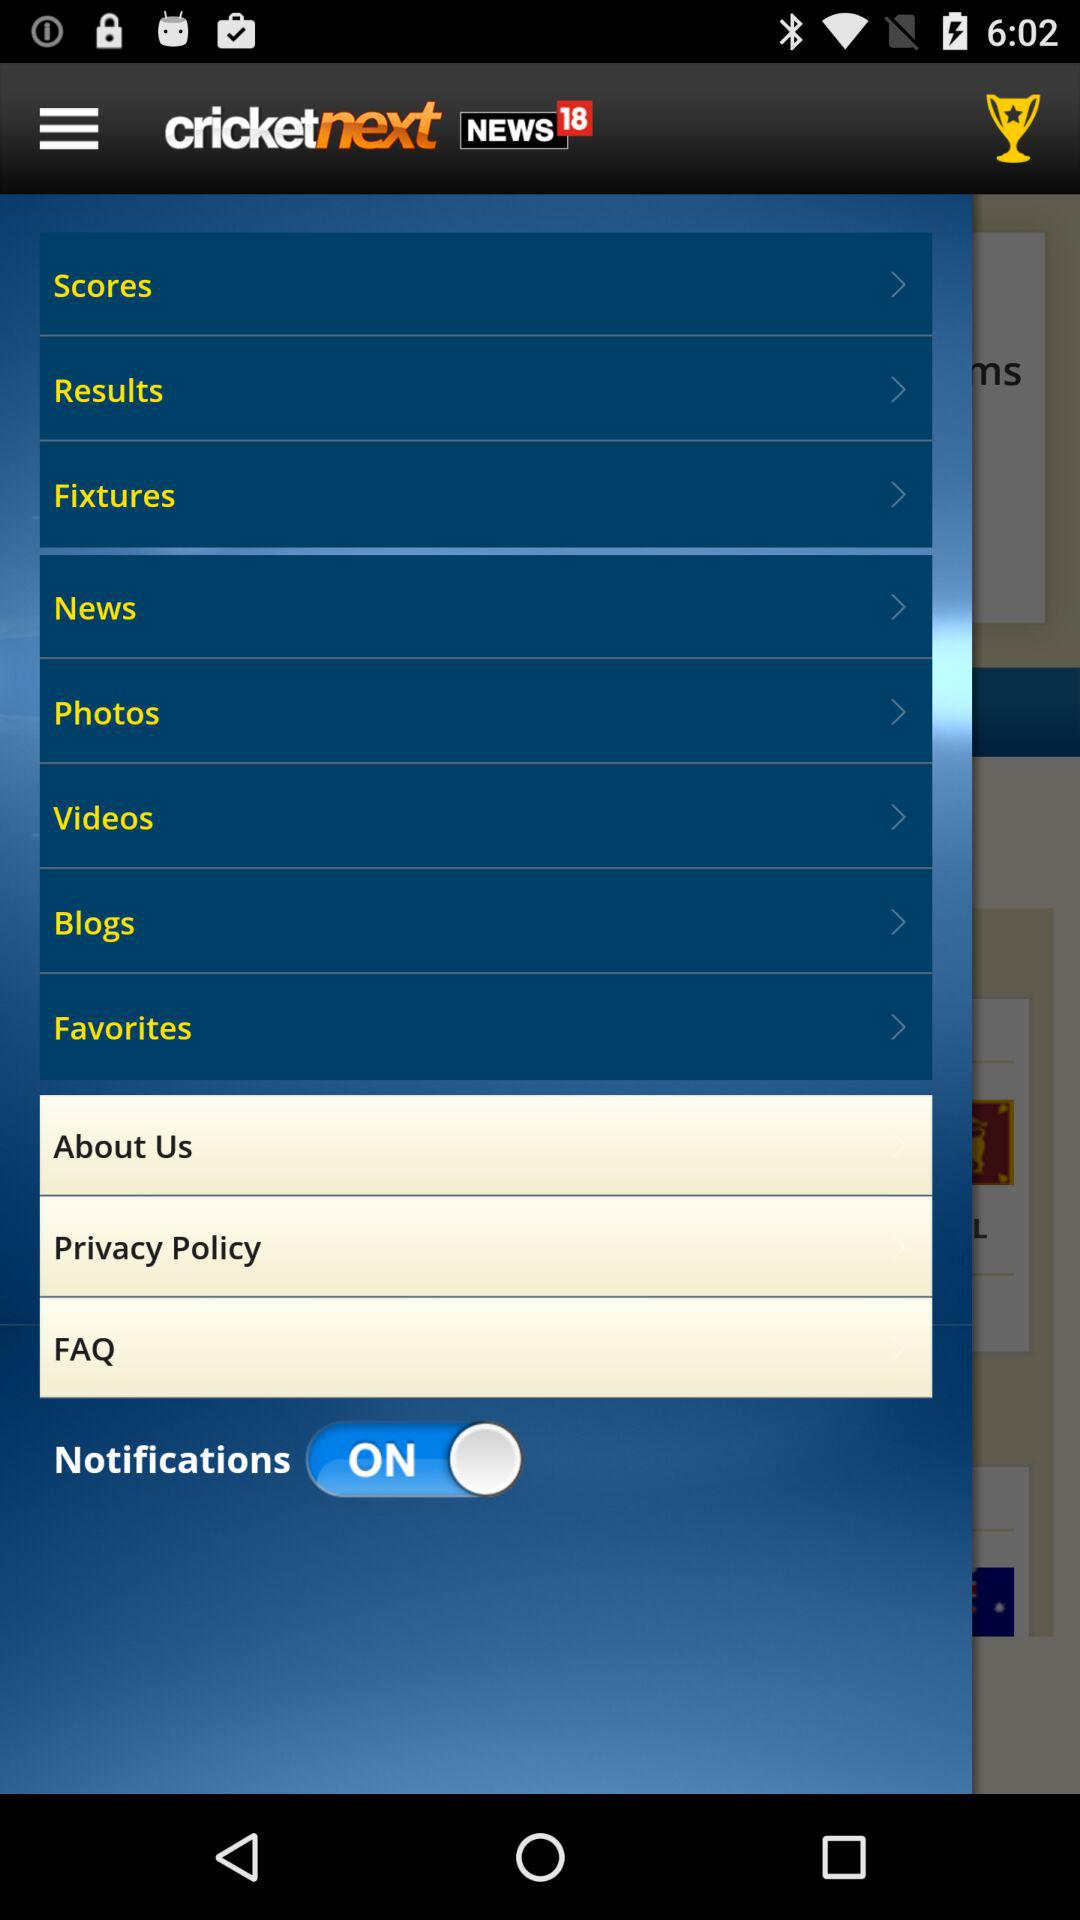What is the status of "Notifications"? The status of "Notifications" is "on". 